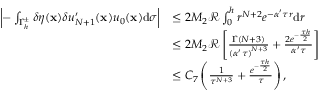<formula> <loc_0><loc_0><loc_500><loc_500>\begin{array} { r l } { \left | - \int _ { { \Gamma _ { h } ^ { \pm } } } \delta \eta ( \mathbf x ) \delta { u _ { N + 1 } ^ { \prime } } ( \mathbf x ) { u _ { 0 } } ( \mathbf x ) \mathrm d \sigma \right | } & { \leq 2 M _ { 2 } \mathcal { R } \int _ { 0 } ^ { h } { { r ^ { N + 2 } } { e ^ { - \alpha ^ { \prime } \tau r } } \mathrm d r } } \\ & { \leq 2 M _ { 2 } \mathcal { R } \left [ { \frac { \Gamma ( N + 3 ) } { { { ( \alpha ^ { \prime } \tau ) } ^ { N + 3 } } } } + { \frac { 2 { e ^ { - { \frac { \tau h } { 2 } } } } } { \alpha ^ { \prime } \tau } } \right ] } \\ & { \leq { C _ { 7 } } \left ( { \frac { 1 } { { \tau ^ { N + 3 } } } } + { \frac { { e ^ { - { \frac { \tau h } { 2 } } } } } { \tau } } \right ) , } \end{array}</formula> 